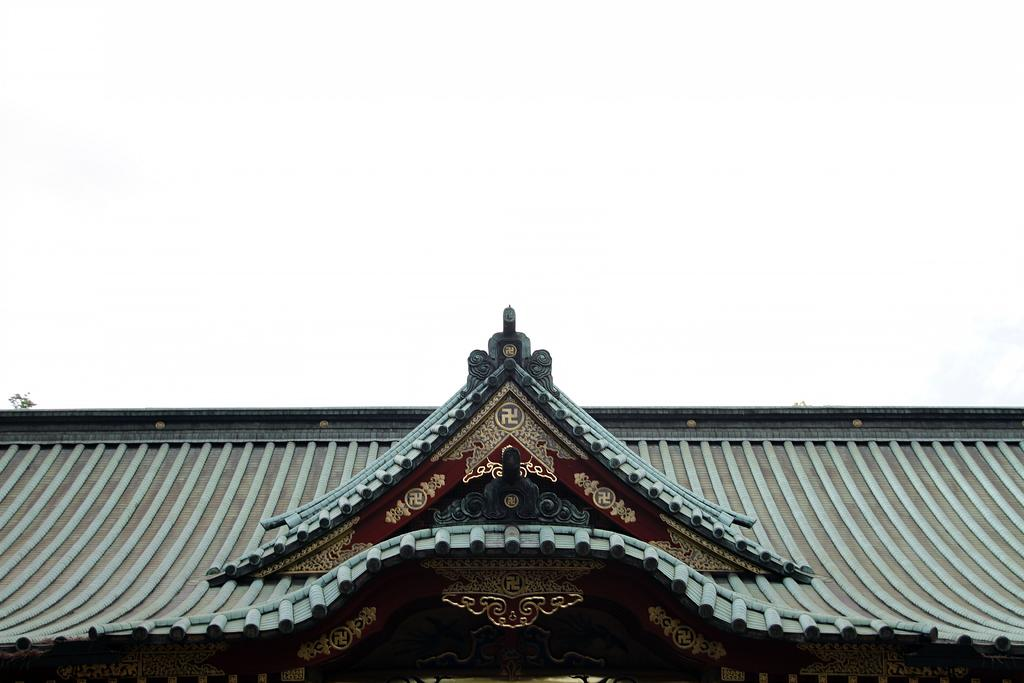What is the main subject of the picture? The main subject of the picture is a house roof. Are there any specific features on the house roof? Yes, there are designs and architecture on the house roof. What can be seen in the background of the picture? The sky is visible behind the house roof. How many feathers can be seen on the road in the image? There are no feathers or roads present in the image; it features a house roof and the sky. 